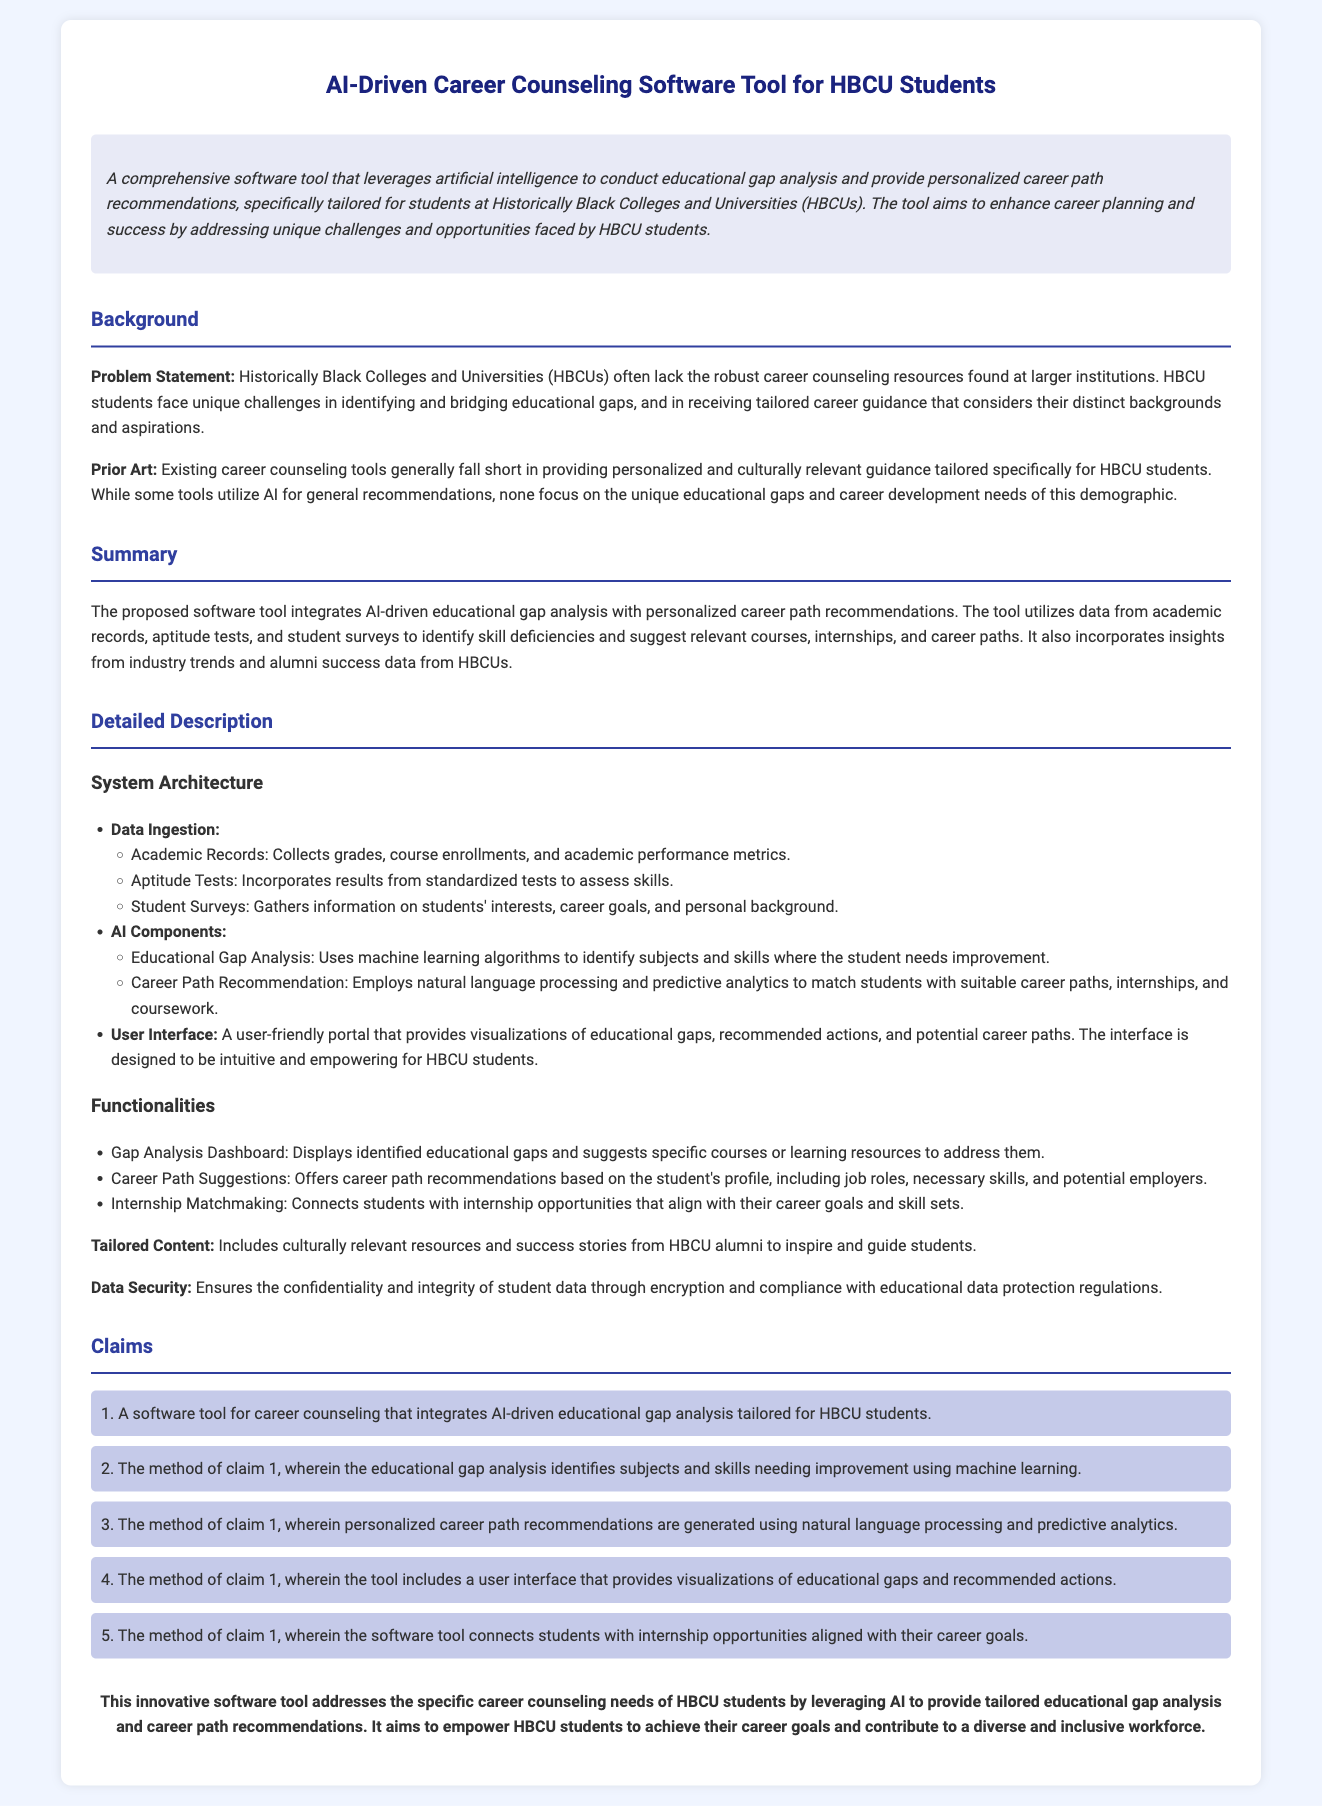What is the title of the software tool? The title of the software tool is presented at the top of the document.
Answer: AI-Driven Career Counseling Software Tool for HBCU Students What unique challenges do HBCU students face according to the problem statement? The document states that HBCU students face unique challenges in identifying and bridging educational gaps.
Answer: Identifying and bridging educational gaps What type of analysis does the software tool utilize for educational gaps? The document describes the use of machine learning algorithms for analyzing educational gaps.
Answer: Machine learning algorithms How many functionalities are listed in the document? The document lists three specific functionalities of the software tool.
Answer: Three What does the Gap Analysis Dashboard display? The Gap Analysis Dashboard is mentioned to display identified educational gaps and suggest specific courses or resources.
Answer: Identified educational gaps What ensures data security for student data in the software tool? The document mentions encryption and compliance with educational data protection regulations.
Answer: Encryption and compliance What feature connects students with internship opportunities? The document describes a feature that matches students with internships aligned with their career goals.
Answer: Internship matchmaking What is the ultimate goal of the software tool according to the conclusion? The conclusion presents the goal of empowering HBCU students to achieve their career goals and contribute to a diverse workforce.
Answer: Achieve their career goals 